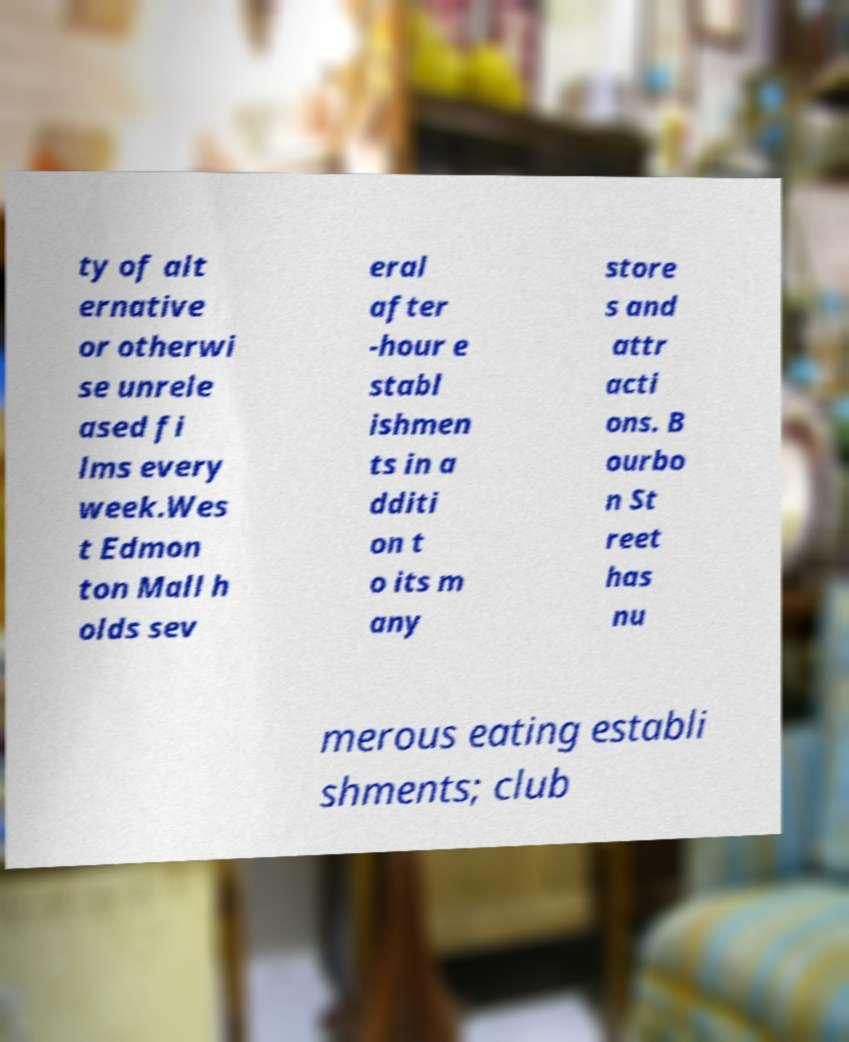Please read and relay the text visible in this image. What does it say? ty of alt ernative or otherwi se unrele ased fi lms every week.Wes t Edmon ton Mall h olds sev eral after -hour e stabl ishmen ts in a dditi on t o its m any store s and attr acti ons. B ourbo n St reet has nu merous eating establi shments; club 